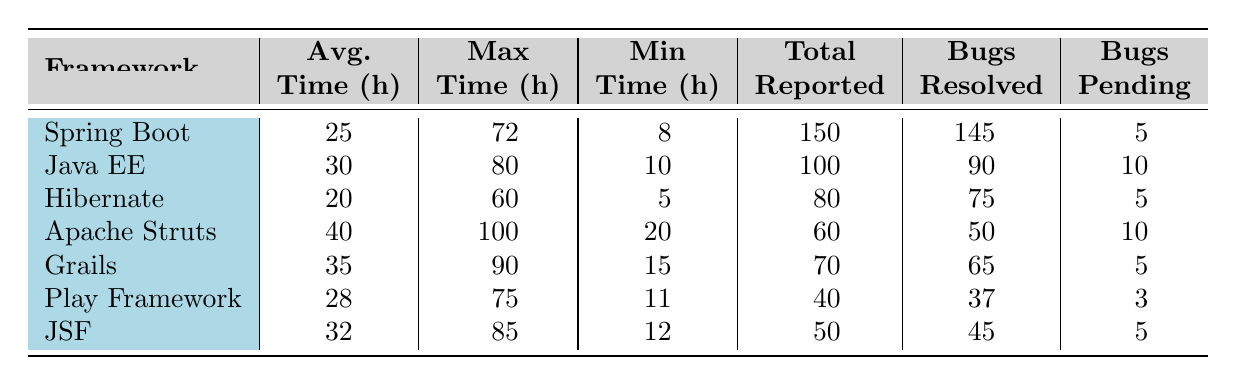What is the average resolution time for Spring Boot? The average resolution time for Spring Boot is listed in the table under the "Avg. Time (h)" column, which shows a value of 25 hours.
Answer: 25 hours Which framework has the maximum resolution time? By examining the "Max Time (h)" column, Apache Struts has the highest value at 100 hours, indicating it has the maximum resolution time.
Answer: Apache Struts How many total bugs were reported for Hibernate? The total bugs reported for Hibernate are shown in the "Total Reported" column as 80.
Answer: 80 What is the average resolution time difference between Grails and Play Framework? The average resolution time for Grails is 35 hours and for Play Framework is 28 hours. The difference is 35 - 28 = 7 hours.
Answer: 7 hours Is the maximum resolution time for Java EE greater than that of Spring Boot? The maximum resolution time for Java EE is 80 hours while for Spring Boot, it is 72 hours. Since 80 > 72, the statement is true.
Answer: Yes What is the total number of bugs resolved across all frameworks? To find this, sum the "Total Resolved" column: 145 + 90 + 75 + 50 + 65 + 37 + 45 = 597. Therefore, the total number of bugs resolved is 597.
Answer: 597 Which framework has the least number of bugs pending? By looking at the "Bugs Pending" column, Play Framework has the least pending bugs with a count of 3.
Answer: Play Framework If we consider the frameworks with an average resolution time below 30 hours, how many have been reported? The frameworks with average resolution times below 30 hours are Hibernate (20), Spring Boot (25), and Play Framework (28). Thus, there are three frameworks with this criterion.
Answer: 3 frameworks How does the average resolution time of JSF compare to that of Grails? JSF has an average resolution time of 32 hours and Grails has 35 hours. JSF's average is less than that of Grails, making the comparison straightforward.
Answer: JSF is less than Grails What is the ratio of resolved bugs to reported bugs for Apache Struts? For Apache Struts, the resolved bugs are 50 and reported bugs are 60. The ratio is 50/60 = 0.833, which simplifies to 5:6.
Answer: 5:6 